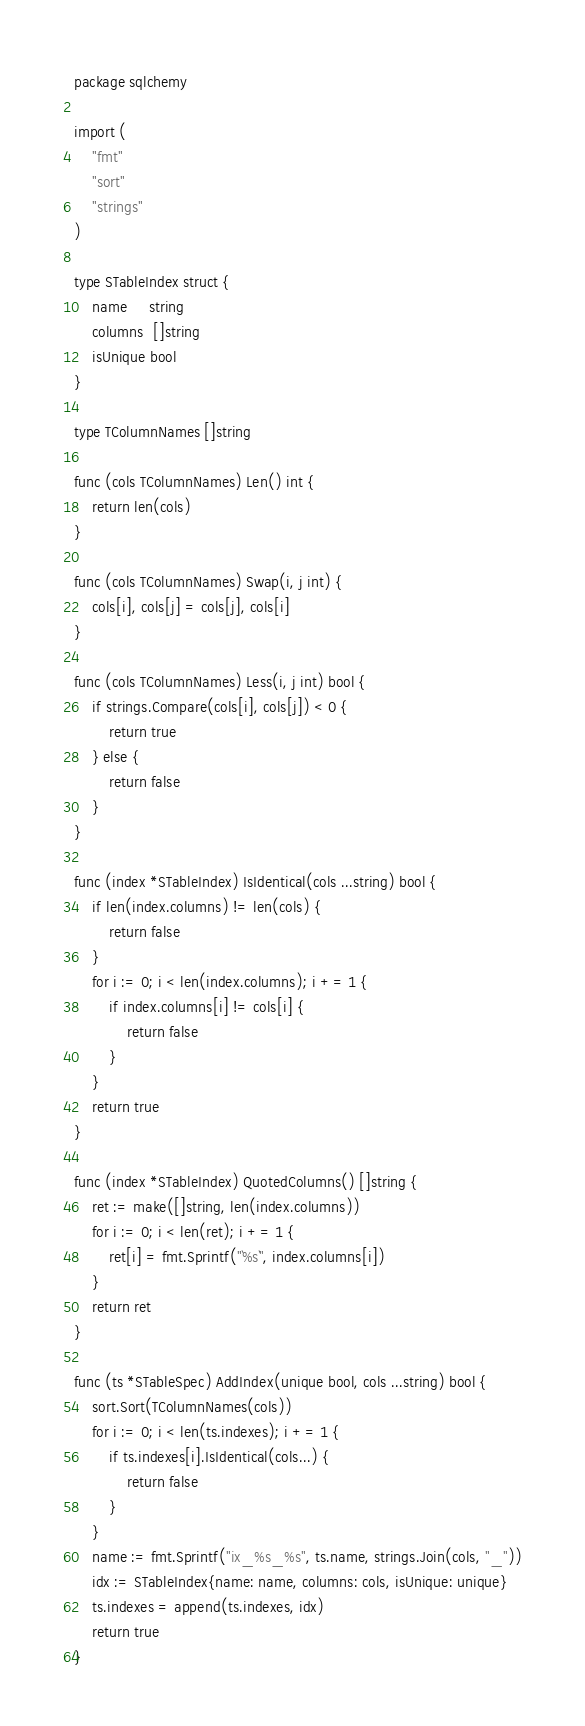Convert code to text. <code><loc_0><loc_0><loc_500><loc_500><_Go_>package sqlchemy

import (
	"fmt"
	"sort"
	"strings"
)

type STableIndex struct {
	name     string
	columns  []string
	isUnique bool
}

type TColumnNames []string

func (cols TColumnNames) Len() int {
	return len(cols)
}

func (cols TColumnNames) Swap(i, j int) {
	cols[i], cols[j] = cols[j], cols[i]
}

func (cols TColumnNames) Less(i, j int) bool {
	if strings.Compare(cols[i], cols[j]) < 0 {
		return true
	} else {
		return false
	}
}

func (index *STableIndex) IsIdentical(cols ...string) bool {
	if len(index.columns) != len(cols) {
		return false
	}
	for i := 0; i < len(index.columns); i += 1 {
		if index.columns[i] != cols[i] {
			return false
		}
	}
	return true
}

func (index *STableIndex) QuotedColumns() []string {
	ret := make([]string, len(index.columns))
	for i := 0; i < len(ret); i += 1 {
		ret[i] = fmt.Sprintf("`%s`", index.columns[i])
	}
	return ret
}

func (ts *STableSpec) AddIndex(unique bool, cols ...string) bool {
	sort.Sort(TColumnNames(cols))
	for i := 0; i < len(ts.indexes); i += 1 {
		if ts.indexes[i].IsIdentical(cols...) {
			return false
		}
	}
	name := fmt.Sprintf("ix_%s_%s", ts.name, strings.Join(cols, "_"))
	idx := STableIndex{name: name, columns: cols, isUnique: unique}
	ts.indexes = append(ts.indexes, idx)
	return true
}
</code> 